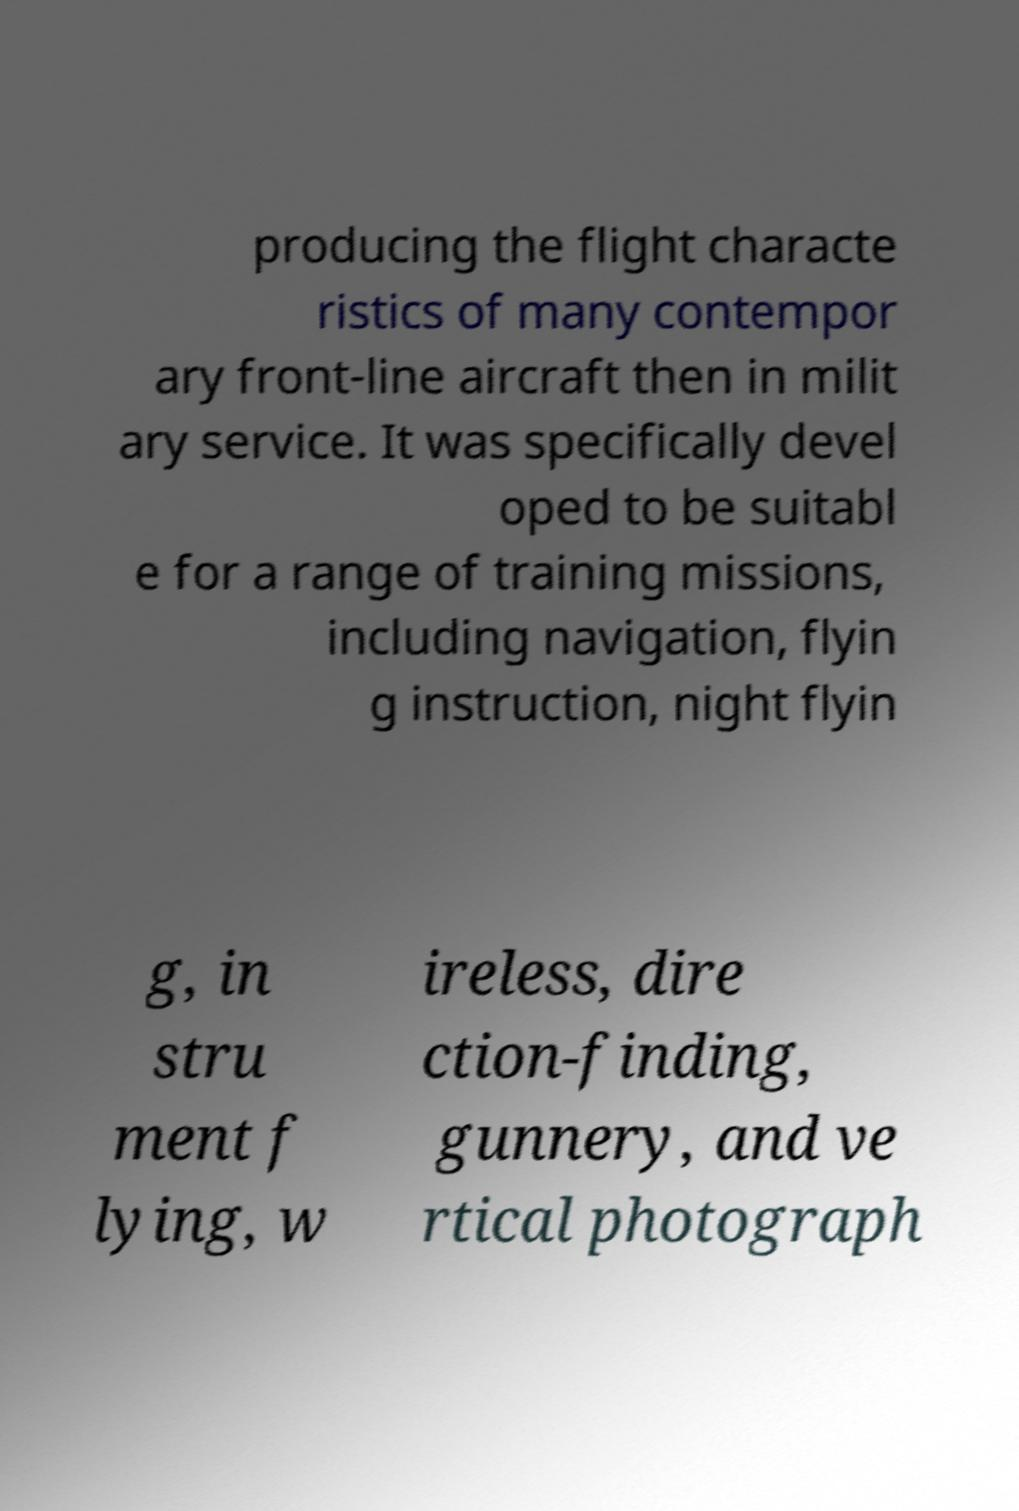For documentation purposes, I need the text within this image transcribed. Could you provide that? producing the flight characte ristics of many contempor ary front-line aircraft then in milit ary service. It was specifically devel oped to be suitabl e for a range of training missions, including navigation, flyin g instruction, night flyin g, in stru ment f lying, w ireless, dire ction-finding, gunnery, and ve rtical photograph 